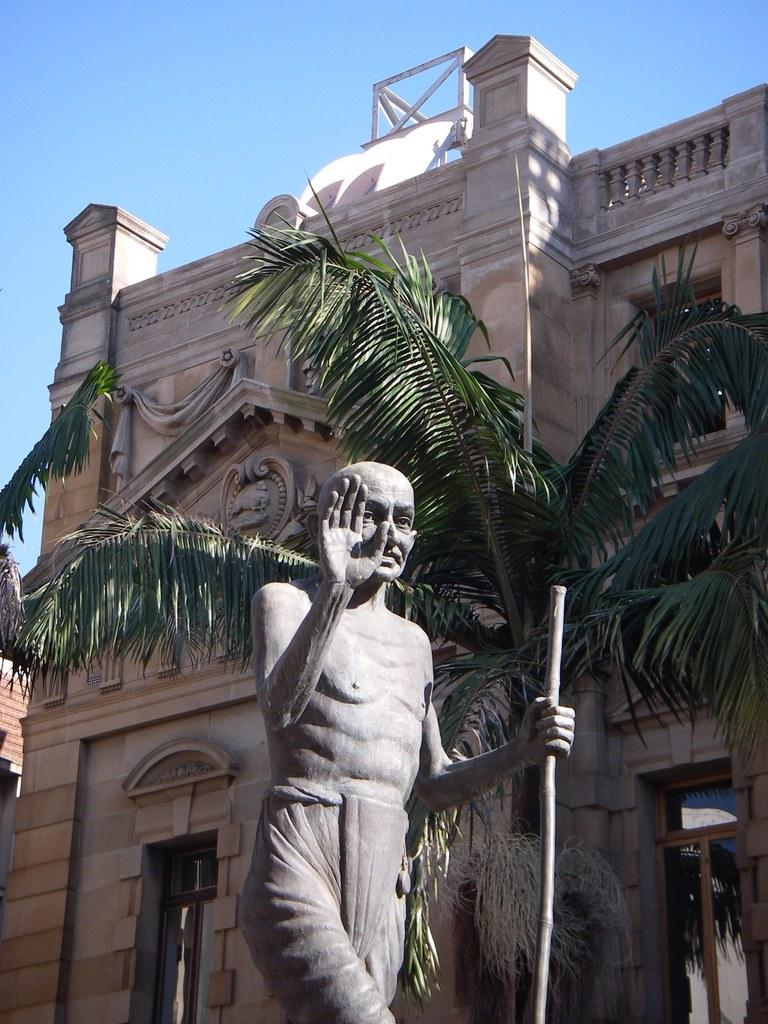What is located at the bottom of the image? There is a statue at the bottom of the image. What can be seen in the middle of the image? There is a tree and a building in the middle of the image. What is visible at the top of the image? The sky is visible at the top of the image. Can you see any guns or bait in the image? No, there are no guns or bait present in the image. Are there any frogs visible in the image? No, there are no frogs visible in the image. 